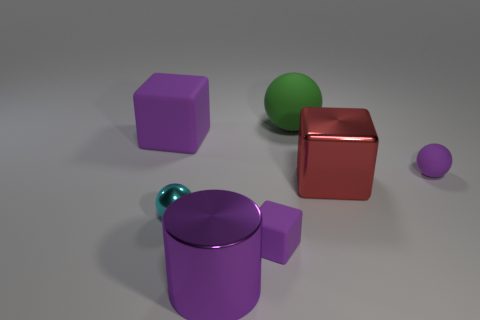Subtract all tiny spheres. How many spheres are left? 1 Add 2 large brown spheres. How many objects exist? 9 Subtract all cyan balls. How many balls are left? 2 Subtract all cylinders. How many objects are left? 6 Add 1 small cyan spheres. How many small cyan spheres are left? 2 Add 2 blue shiny cylinders. How many blue shiny cylinders exist? 2 Subtract 2 purple blocks. How many objects are left? 5 Subtract 1 balls. How many balls are left? 2 Subtract all yellow blocks. Subtract all yellow cylinders. How many blocks are left? 3 Subtract all green cubes. How many purple spheres are left? 1 